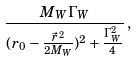Convert formula to latex. <formula><loc_0><loc_0><loc_500><loc_500>\frac { M _ { W } \Gamma _ { W } } { ( r _ { 0 } - \frac { \vec { r } ^ { \, 2 } } { 2 M _ { W } } ) ^ { 2 } + \frac { \Gamma _ { W } ^ { 2 } } { 4 } } \, ,</formula> 